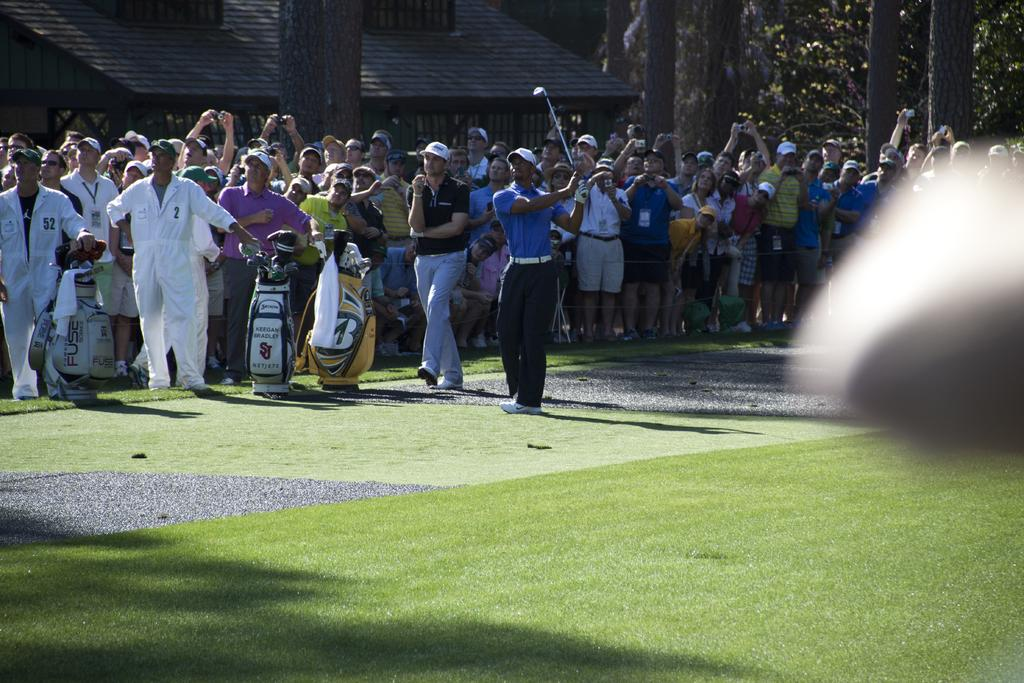What is the main subject of the image? There is a person standing in the center of the image. What is the person holding in the image? The person is holding a golf bat. How many people are present in the image? There are many people present in the image. What can be seen in the background of the image? There is a building and trees in the background of the image. What type of vase can be seen in the image? There is no vase present in the image. What experience might the person holding the golf bat be having in the image? The image does not provide any information about the person's experience, so it cannot be determined from the image. 